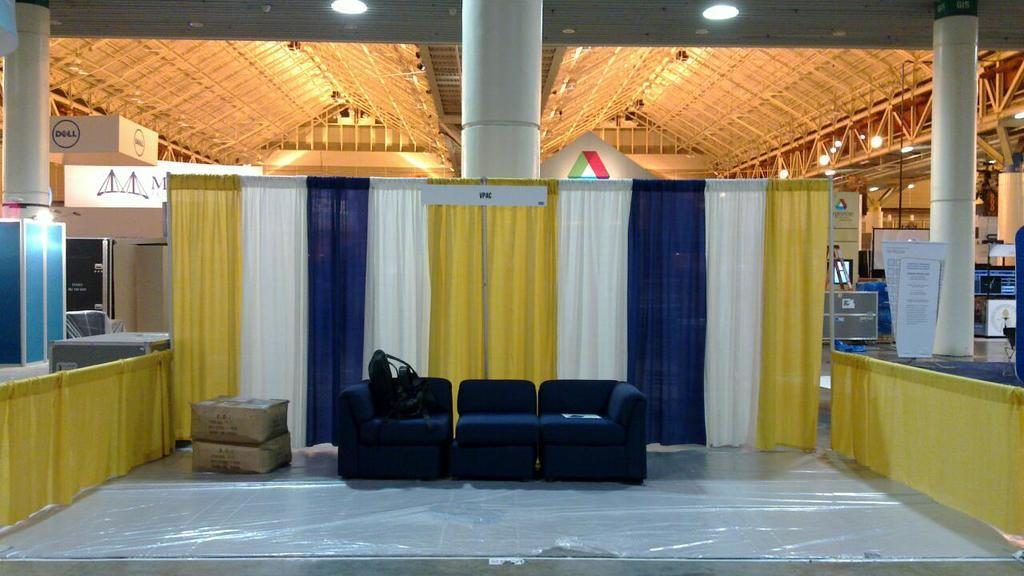What type of furniture is present in the image? There is a sofa in the image. What objects are present in the image that might be used for storage or organization? There are boxes in the image. What type of material is visible in the image? There is a cloth in the image. What architectural feature can be seen in the image? There is a pillar in the image. What structure is present above the scene in the image? There is a roof in the image. What sources of illumination are present in the image? There are lights in the image. What type of coat is draped over the sofa in the image? There is no coat present in the image; only a sofa, boxes, a cloth, a pillar, a roof, and lights are visible. What rate of inflation is mentioned in the image? There is no mention of inflation or any rates in the image. 